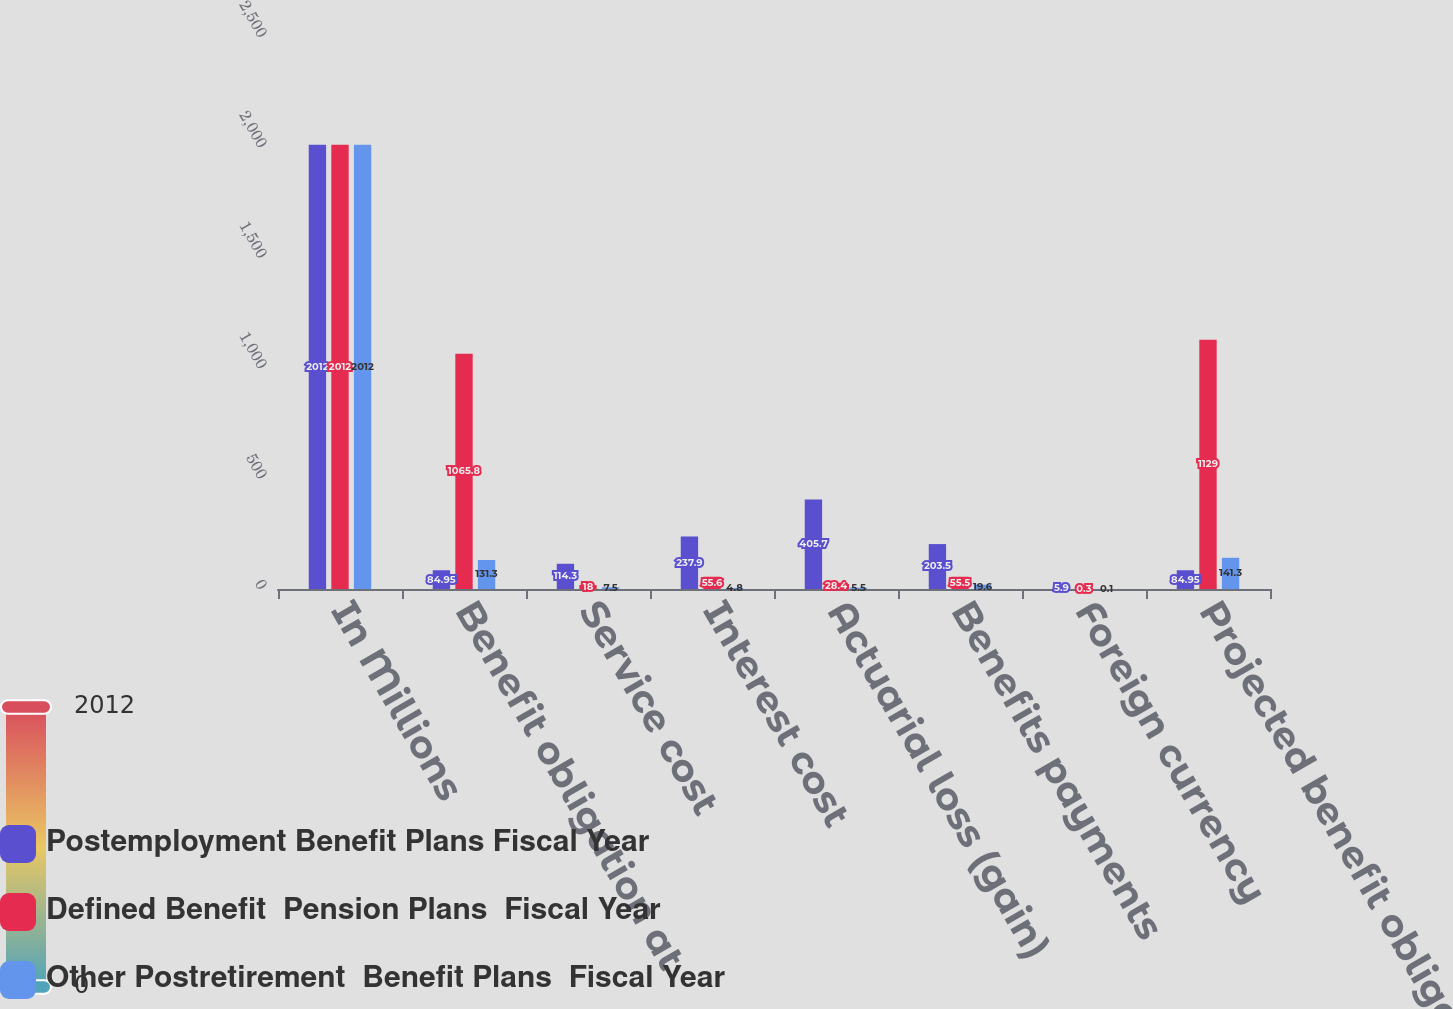<chart> <loc_0><loc_0><loc_500><loc_500><stacked_bar_chart><ecel><fcel>In Millions<fcel>Benefit obligation at<fcel>Service cost<fcel>Interest cost<fcel>Actuarial loss (gain)<fcel>Benefits payments<fcel>Foreign currency<fcel>Projected benefit obligation<nl><fcel>Postemployment Benefit Plans Fiscal Year<fcel>2012<fcel>84.95<fcel>114.3<fcel>237.9<fcel>405.7<fcel>203.5<fcel>5.9<fcel>84.95<nl><fcel>Defined Benefit  Pension Plans  Fiscal Year<fcel>2012<fcel>1065.8<fcel>18<fcel>55.6<fcel>28.4<fcel>55.5<fcel>0.3<fcel>1129<nl><fcel>Other Postretirement  Benefit Plans  Fiscal Year<fcel>2012<fcel>131.3<fcel>7.5<fcel>4.8<fcel>5.5<fcel>19.6<fcel>0.1<fcel>141.3<nl></chart> 